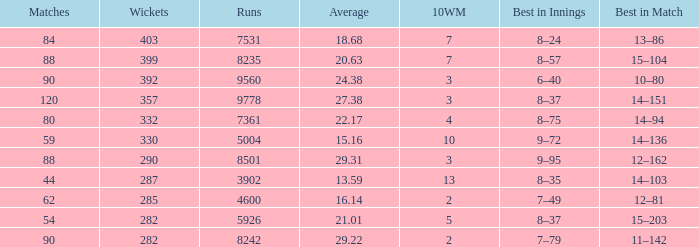What is the sum of runs that are associated with 10WM values over 13? None. 